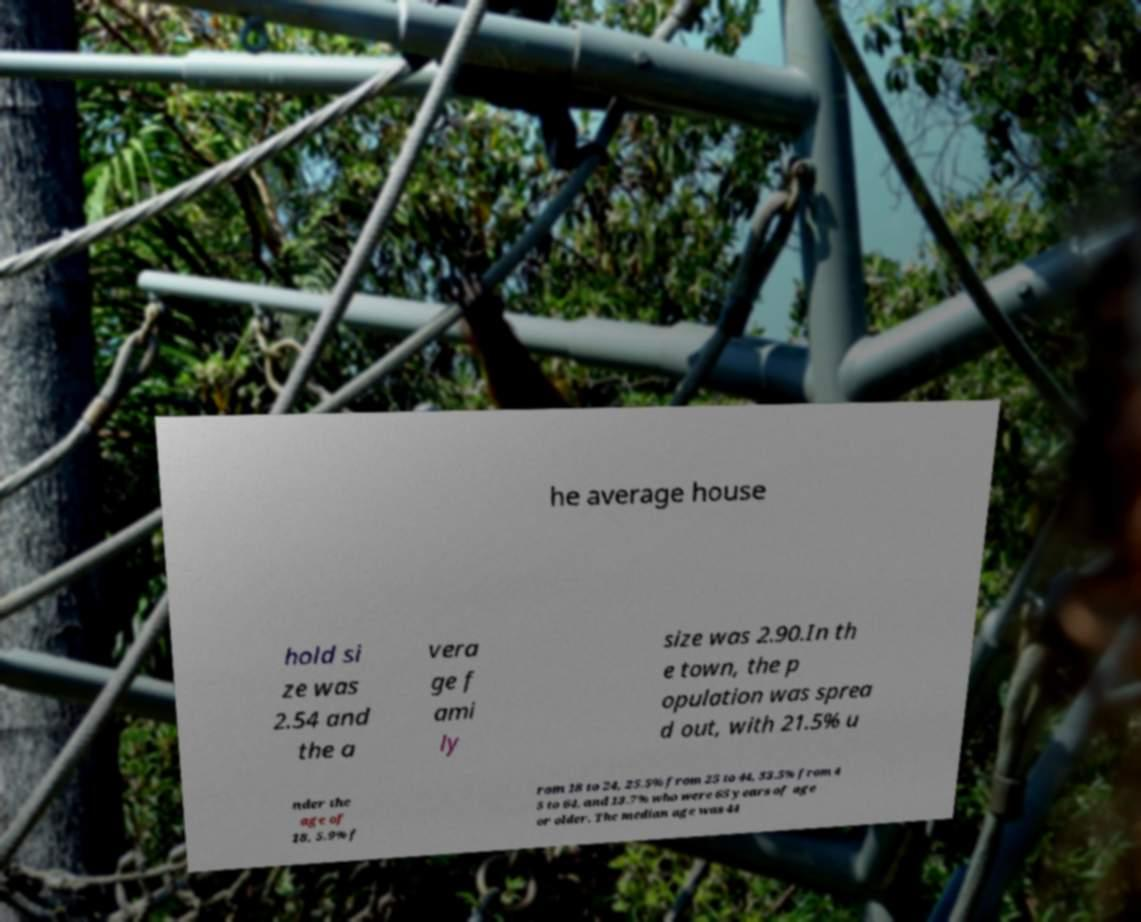Could you assist in decoding the text presented in this image and type it out clearly? he average house hold si ze was 2.54 and the a vera ge f ami ly size was 2.90.In th e town, the p opulation was sprea d out, with 21.5% u nder the age of 18, 5.9% f rom 18 to 24, 25.5% from 25 to 44, 33.5% from 4 5 to 64, and 13.7% who were 65 years of age or older. The median age was 44 